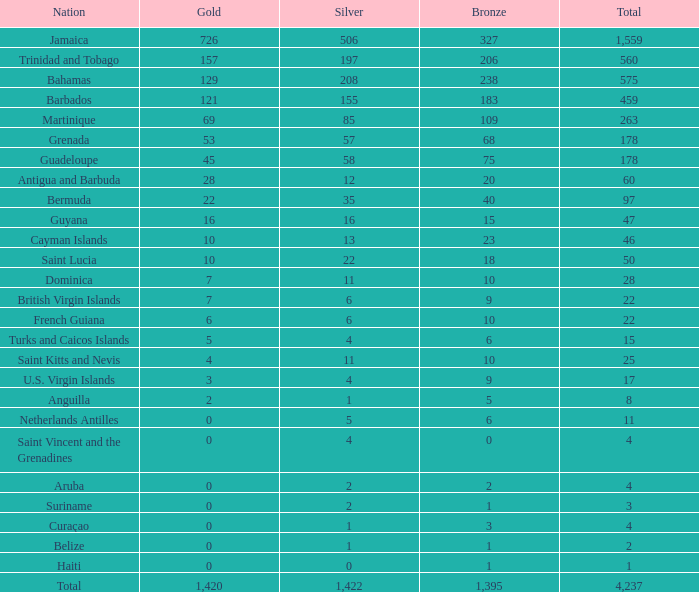How many silver medals does saint kitts and nevis have, given that gold is larger than 0, bronze is smaller than 23, total is larger than 22? 1.0. 